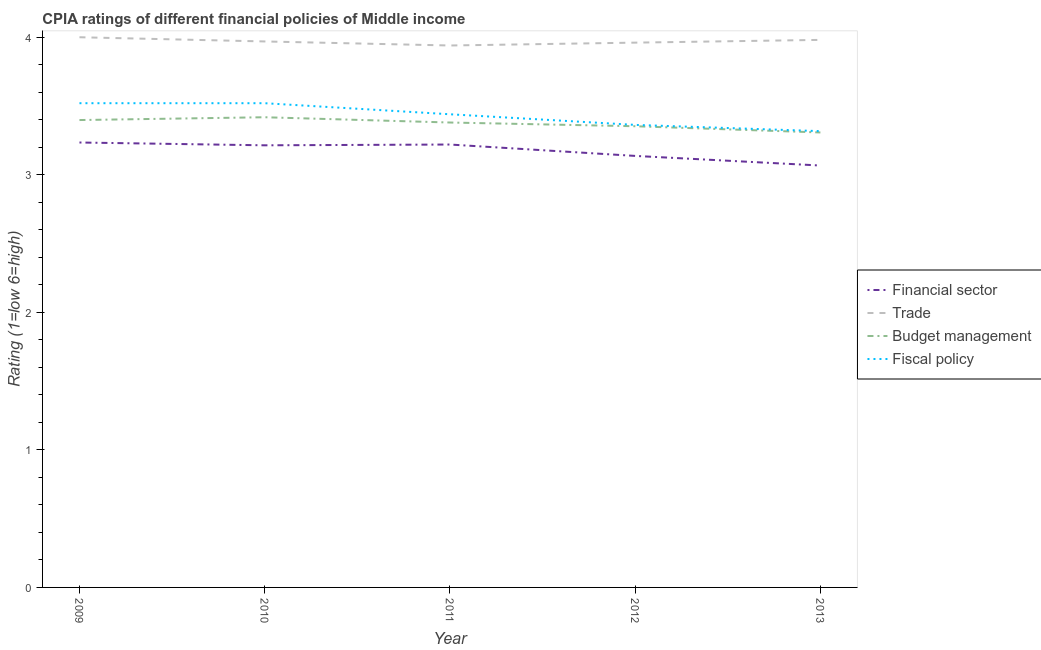How many different coloured lines are there?
Offer a very short reply. 4. Is the number of lines equal to the number of legend labels?
Your answer should be very brief. Yes. What is the cpia rating of fiscal policy in 2010?
Provide a short and direct response. 3.52. Across all years, what is the maximum cpia rating of budget management?
Provide a short and direct response. 3.42. Across all years, what is the minimum cpia rating of budget management?
Make the answer very short. 3.31. In which year was the cpia rating of fiscal policy maximum?
Provide a succinct answer. 2009. In which year was the cpia rating of trade minimum?
Offer a very short reply. 2011. What is the total cpia rating of financial sector in the graph?
Provide a short and direct response. 15.87. What is the difference between the cpia rating of fiscal policy in 2011 and that in 2012?
Your response must be concise. 0.08. What is the difference between the cpia rating of financial sector in 2012 and the cpia rating of fiscal policy in 2010?
Make the answer very short. -0.38. What is the average cpia rating of financial sector per year?
Your response must be concise. 3.17. In the year 2010, what is the difference between the cpia rating of budget management and cpia rating of trade?
Keep it short and to the point. -0.55. In how many years, is the cpia rating of fiscal policy greater than 2.8?
Your response must be concise. 5. What is the ratio of the cpia rating of budget management in 2009 to that in 2011?
Your response must be concise. 1.01. Is the difference between the cpia rating of trade in 2009 and 2011 greater than the difference between the cpia rating of financial sector in 2009 and 2011?
Your response must be concise. Yes. What is the difference between the highest and the second highest cpia rating of trade?
Provide a short and direct response. 0.02. What is the difference between the highest and the lowest cpia rating of budget management?
Provide a short and direct response. 0.11. In how many years, is the cpia rating of financial sector greater than the average cpia rating of financial sector taken over all years?
Your response must be concise. 3. Is it the case that in every year, the sum of the cpia rating of financial sector and cpia rating of trade is greater than the cpia rating of budget management?
Provide a short and direct response. Yes. Does the cpia rating of trade monotonically increase over the years?
Your response must be concise. No. Is the cpia rating of financial sector strictly greater than the cpia rating of budget management over the years?
Offer a terse response. No. Is the cpia rating of budget management strictly less than the cpia rating of financial sector over the years?
Provide a short and direct response. No. How many lines are there?
Ensure brevity in your answer.  4. How many years are there in the graph?
Offer a very short reply. 5. Does the graph contain any zero values?
Make the answer very short. No. Where does the legend appear in the graph?
Keep it short and to the point. Center right. What is the title of the graph?
Provide a short and direct response. CPIA ratings of different financial policies of Middle income. Does "Primary" appear as one of the legend labels in the graph?
Make the answer very short. No. What is the label or title of the X-axis?
Offer a very short reply. Year. What is the label or title of the Y-axis?
Offer a very short reply. Rating (1=low 6=high). What is the Rating (1=low 6=high) in Financial sector in 2009?
Your response must be concise. 3.23. What is the Rating (1=low 6=high) in Budget management in 2009?
Ensure brevity in your answer.  3.4. What is the Rating (1=low 6=high) of Fiscal policy in 2009?
Your answer should be very brief. 3.52. What is the Rating (1=low 6=high) of Financial sector in 2010?
Ensure brevity in your answer.  3.21. What is the Rating (1=low 6=high) in Trade in 2010?
Give a very brief answer. 3.97. What is the Rating (1=low 6=high) of Budget management in 2010?
Your response must be concise. 3.42. What is the Rating (1=low 6=high) of Fiscal policy in 2010?
Your answer should be very brief. 3.52. What is the Rating (1=low 6=high) in Financial sector in 2011?
Your response must be concise. 3.22. What is the Rating (1=low 6=high) of Trade in 2011?
Keep it short and to the point. 3.94. What is the Rating (1=low 6=high) in Budget management in 2011?
Your response must be concise. 3.38. What is the Rating (1=low 6=high) in Fiscal policy in 2011?
Ensure brevity in your answer.  3.44. What is the Rating (1=low 6=high) in Financial sector in 2012?
Give a very brief answer. 3.14. What is the Rating (1=low 6=high) in Trade in 2012?
Make the answer very short. 3.96. What is the Rating (1=low 6=high) in Budget management in 2012?
Offer a very short reply. 3.35. What is the Rating (1=low 6=high) of Fiscal policy in 2012?
Offer a terse response. 3.36. What is the Rating (1=low 6=high) in Financial sector in 2013?
Provide a succinct answer. 3.07. What is the Rating (1=low 6=high) in Trade in 2013?
Offer a very short reply. 3.98. What is the Rating (1=low 6=high) of Budget management in 2013?
Offer a terse response. 3.31. What is the Rating (1=low 6=high) in Fiscal policy in 2013?
Keep it short and to the point. 3.32. Across all years, what is the maximum Rating (1=low 6=high) in Financial sector?
Provide a short and direct response. 3.23. Across all years, what is the maximum Rating (1=low 6=high) in Trade?
Your answer should be compact. 4. Across all years, what is the maximum Rating (1=low 6=high) in Budget management?
Offer a very short reply. 3.42. Across all years, what is the maximum Rating (1=low 6=high) in Fiscal policy?
Your answer should be very brief. 3.52. Across all years, what is the minimum Rating (1=low 6=high) in Financial sector?
Your response must be concise. 3.07. Across all years, what is the minimum Rating (1=low 6=high) of Trade?
Provide a succinct answer. 3.94. Across all years, what is the minimum Rating (1=low 6=high) in Budget management?
Offer a very short reply. 3.31. Across all years, what is the minimum Rating (1=low 6=high) of Fiscal policy?
Give a very brief answer. 3.32. What is the total Rating (1=low 6=high) in Financial sector in the graph?
Give a very brief answer. 15.87. What is the total Rating (1=low 6=high) of Trade in the graph?
Offer a very short reply. 19.85. What is the total Rating (1=low 6=high) in Budget management in the graph?
Keep it short and to the point. 16.86. What is the total Rating (1=low 6=high) of Fiscal policy in the graph?
Your response must be concise. 17.16. What is the difference between the Rating (1=low 6=high) of Financial sector in 2009 and that in 2010?
Your answer should be compact. 0.02. What is the difference between the Rating (1=low 6=high) of Trade in 2009 and that in 2010?
Offer a very short reply. 0.03. What is the difference between the Rating (1=low 6=high) of Budget management in 2009 and that in 2010?
Your answer should be very brief. -0.02. What is the difference between the Rating (1=low 6=high) of Financial sector in 2009 and that in 2011?
Offer a terse response. 0.01. What is the difference between the Rating (1=low 6=high) in Trade in 2009 and that in 2011?
Your response must be concise. 0.06. What is the difference between the Rating (1=low 6=high) in Budget management in 2009 and that in 2011?
Ensure brevity in your answer.  0.02. What is the difference between the Rating (1=low 6=high) in Fiscal policy in 2009 and that in 2011?
Offer a terse response. 0.08. What is the difference between the Rating (1=low 6=high) in Financial sector in 2009 and that in 2012?
Your answer should be very brief. 0.1. What is the difference between the Rating (1=low 6=high) of Trade in 2009 and that in 2012?
Your answer should be compact. 0.04. What is the difference between the Rating (1=low 6=high) of Budget management in 2009 and that in 2012?
Provide a short and direct response. 0.04. What is the difference between the Rating (1=low 6=high) of Fiscal policy in 2009 and that in 2012?
Your response must be concise. 0.16. What is the difference between the Rating (1=low 6=high) in Financial sector in 2009 and that in 2013?
Ensure brevity in your answer.  0.17. What is the difference between the Rating (1=low 6=high) in Trade in 2009 and that in 2013?
Your answer should be very brief. 0.02. What is the difference between the Rating (1=low 6=high) of Budget management in 2009 and that in 2013?
Offer a very short reply. 0.09. What is the difference between the Rating (1=low 6=high) in Fiscal policy in 2009 and that in 2013?
Provide a succinct answer. 0.2. What is the difference between the Rating (1=low 6=high) of Financial sector in 2010 and that in 2011?
Provide a short and direct response. -0.01. What is the difference between the Rating (1=low 6=high) of Trade in 2010 and that in 2011?
Your answer should be very brief. 0.03. What is the difference between the Rating (1=low 6=high) in Budget management in 2010 and that in 2011?
Provide a succinct answer. 0.04. What is the difference between the Rating (1=low 6=high) in Fiscal policy in 2010 and that in 2011?
Offer a very short reply. 0.08. What is the difference between the Rating (1=low 6=high) in Financial sector in 2010 and that in 2012?
Your answer should be compact. 0.08. What is the difference between the Rating (1=low 6=high) of Trade in 2010 and that in 2012?
Provide a succinct answer. 0.01. What is the difference between the Rating (1=low 6=high) in Budget management in 2010 and that in 2012?
Provide a short and direct response. 0.07. What is the difference between the Rating (1=low 6=high) in Fiscal policy in 2010 and that in 2012?
Make the answer very short. 0.16. What is the difference between the Rating (1=low 6=high) in Financial sector in 2010 and that in 2013?
Your response must be concise. 0.15. What is the difference between the Rating (1=low 6=high) in Trade in 2010 and that in 2013?
Provide a short and direct response. -0.01. What is the difference between the Rating (1=low 6=high) of Budget management in 2010 and that in 2013?
Your answer should be very brief. 0.11. What is the difference between the Rating (1=low 6=high) of Fiscal policy in 2010 and that in 2013?
Offer a terse response. 0.2. What is the difference between the Rating (1=low 6=high) in Financial sector in 2011 and that in 2012?
Ensure brevity in your answer.  0.08. What is the difference between the Rating (1=low 6=high) of Trade in 2011 and that in 2012?
Offer a terse response. -0.02. What is the difference between the Rating (1=low 6=high) in Budget management in 2011 and that in 2012?
Give a very brief answer. 0.03. What is the difference between the Rating (1=low 6=high) of Fiscal policy in 2011 and that in 2012?
Provide a succinct answer. 0.08. What is the difference between the Rating (1=low 6=high) in Financial sector in 2011 and that in 2013?
Make the answer very short. 0.15. What is the difference between the Rating (1=low 6=high) of Trade in 2011 and that in 2013?
Give a very brief answer. -0.04. What is the difference between the Rating (1=low 6=high) in Budget management in 2011 and that in 2013?
Your response must be concise. 0.07. What is the difference between the Rating (1=low 6=high) of Fiscal policy in 2011 and that in 2013?
Provide a short and direct response. 0.12. What is the difference between the Rating (1=low 6=high) in Financial sector in 2012 and that in 2013?
Make the answer very short. 0.07. What is the difference between the Rating (1=low 6=high) of Trade in 2012 and that in 2013?
Provide a succinct answer. -0.02. What is the difference between the Rating (1=low 6=high) in Budget management in 2012 and that in 2013?
Your response must be concise. 0.05. What is the difference between the Rating (1=low 6=high) of Fiscal policy in 2012 and that in 2013?
Give a very brief answer. 0.05. What is the difference between the Rating (1=low 6=high) of Financial sector in 2009 and the Rating (1=low 6=high) of Trade in 2010?
Ensure brevity in your answer.  -0.73. What is the difference between the Rating (1=low 6=high) in Financial sector in 2009 and the Rating (1=low 6=high) in Budget management in 2010?
Ensure brevity in your answer.  -0.18. What is the difference between the Rating (1=low 6=high) in Financial sector in 2009 and the Rating (1=low 6=high) in Fiscal policy in 2010?
Offer a very short reply. -0.29. What is the difference between the Rating (1=low 6=high) of Trade in 2009 and the Rating (1=low 6=high) of Budget management in 2010?
Keep it short and to the point. 0.58. What is the difference between the Rating (1=low 6=high) of Trade in 2009 and the Rating (1=low 6=high) of Fiscal policy in 2010?
Keep it short and to the point. 0.48. What is the difference between the Rating (1=low 6=high) in Budget management in 2009 and the Rating (1=low 6=high) in Fiscal policy in 2010?
Ensure brevity in your answer.  -0.12. What is the difference between the Rating (1=low 6=high) in Financial sector in 2009 and the Rating (1=low 6=high) in Trade in 2011?
Your answer should be very brief. -0.71. What is the difference between the Rating (1=low 6=high) of Financial sector in 2009 and the Rating (1=low 6=high) of Budget management in 2011?
Offer a very short reply. -0.15. What is the difference between the Rating (1=low 6=high) of Financial sector in 2009 and the Rating (1=low 6=high) of Fiscal policy in 2011?
Ensure brevity in your answer.  -0.21. What is the difference between the Rating (1=low 6=high) of Trade in 2009 and the Rating (1=low 6=high) of Budget management in 2011?
Your response must be concise. 0.62. What is the difference between the Rating (1=low 6=high) of Trade in 2009 and the Rating (1=low 6=high) of Fiscal policy in 2011?
Ensure brevity in your answer.  0.56. What is the difference between the Rating (1=low 6=high) in Budget management in 2009 and the Rating (1=low 6=high) in Fiscal policy in 2011?
Keep it short and to the point. -0.04. What is the difference between the Rating (1=low 6=high) in Financial sector in 2009 and the Rating (1=low 6=high) in Trade in 2012?
Your answer should be very brief. -0.73. What is the difference between the Rating (1=low 6=high) of Financial sector in 2009 and the Rating (1=low 6=high) of Budget management in 2012?
Provide a succinct answer. -0.12. What is the difference between the Rating (1=low 6=high) in Financial sector in 2009 and the Rating (1=low 6=high) in Fiscal policy in 2012?
Offer a very short reply. -0.13. What is the difference between the Rating (1=low 6=high) of Trade in 2009 and the Rating (1=low 6=high) of Budget management in 2012?
Provide a succinct answer. 0.65. What is the difference between the Rating (1=low 6=high) in Trade in 2009 and the Rating (1=low 6=high) in Fiscal policy in 2012?
Make the answer very short. 0.64. What is the difference between the Rating (1=low 6=high) of Budget management in 2009 and the Rating (1=low 6=high) of Fiscal policy in 2012?
Give a very brief answer. 0.04. What is the difference between the Rating (1=low 6=high) of Financial sector in 2009 and the Rating (1=low 6=high) of Trade in 2013?
Your answer should be compact. -0.75. What is the difference between the Rating (1=low 6=high) in Financial sector in 2009 and the Rating (1=low 6=high) in Budget management in 2013?
Provide a short and direct response. -0.07. What is the difference between the Rating (1=low 6=high) in Financial sector in 2009 and the Rating (1=low 6=high) in Fiscal policy in 2013?
Make the answer very short. -0.08. What is the difference between the Rating (1=low 6=high) in Trade in 2009 and the Rating (1=low 6=high) in Budget management in 2013?
Offer a very short reply. 0.69. What is the difference between the Rating (1=low 6=high) of Trade in 2009 and the Rating (1=low 6=high) of Fiscal policy in 2013?
Provide a short and direct response. 0.68. What is the difference between the Rating (1=low 6=high) of Budget management in 2009 and the Rating (1=low 6=high) of Fiscal policy in 2013?
Your answer should be very brief. 0.08. What is the difference between the Rating (1=low 6=high) of Financial sector in 2010 and the Rating (1=low 6=high) of Trade in 2011?
Give a very brief answer. -0.73. What is the difference between the Rating (1=low 6=high) of Financial sector in 2010 and the Rating (1=low 6=high) of Budget management in 2011?
Offer a very short reply. -0.17. What is the difference between the Rating (1=low 6=high) of Financial sector in 2010 and the Rating (1=low 6=high) of Fiscal policy in 2011?
Give a very brief answer. -0.23. What is the difference between the Rating (1=low 6=high) of Trade in 2010 and the Rating (1=low 6=high) of Budget management in 2011?
Provide a short and direct response. 0.59. What is the difference between the Rating (1=low 6=high) in Trade in 2010 and the Rating (1=low 6=high) in Fiscal policy in 2011?
Offer a terse response. 0.53. What is the difference between the Rating (1=low 6=high) in Budget management in 2010 and the Rating (1=low 6=high) in Fiscal policy in 2011?
Make the answer very short. -0.02. What is the difference between the Rating (1=low 6=high) in Financial sector in 2010 and the Rating (1=low 6=high) in Trade in 2012?
Provide a succinct answer. -0.75. What is the difference between the Rating (1=low 6=high) of Financial sector in 2010 and the Rating (1=low 6=high) of Budget management in 2012?
Make the answer very short. -0.14. What is the difference between the Rating (1=low 6=high) in Financial sector in 2010 and the Rating (1=low 6=high) in Fiscal policy in 2012?
Your answer should be compact. -0.15. What is the difference between the Rating (1=low 6=high) in Trade in 2010 and the Rating (1=low 6=high) in Budget management in 2012?
Provide a succinct answer. 0.62. What is the difference between the Rating (1=low 6=high) of Trade in 2010 and the Rating (1=low 6=high) of Fiscal policy in 2012?
Your answer should be very brief. 0.61. What is the difference between the Rating (1=low 6=high) in Budget management in 2010 and the Rating (1=low 6=high) in Fiscal policy in 2012?
Your response must be concise. 0.06. What is the difference between the Rating (1=low 6=high) in Financial sector in 2010 and the Rating (1=low 6=high) in Trade in 2013?
Your response must be concise. -0.77. What is the difference between the Rating (1=low 6=high) of Financial sector in 2010 and the Rating (1=low 6=high) of Budget management in 2013?
Give a very brief answer. -0.09. What is the difference between the Rating (1=low 6=high) of Financial sector in 2010 and the Rating (1=low 6=high) of Fiscal policy in 2013?
Give a very brief answer. -0.1. What is the difference between the Rating (1=low 6=high) of Trade in 2010 and the Rating (1=low 6=high) of Budget management in 2013?
Ensure brevity in your answer.  0.66. What is the difference between the Rating (1=low 6=high) in Trade in 2010 and the Rating (1=low 6=high) in Fiscal policy in 2013?
Offer a very short reply. 0.65. What is the difference between the Rating (1=low 6=high) in Budget management in 2010 and the Rating (1=low 6=high) in Fiscal policy in 2013?
Offer a terse response. 0.1. What is the difference between the Rating (1=low 6=high) in Financial sector in 2011 and the Rating (1=low 6=high) in Trade in 2012?
Your answer should be compact. -0.74. What is the difference between the Rating (1=low 6=high) of Financial sector in 2011 and the Rating (1=low 6=high) of Budget management in 2012?
Offer a very short reply. -0.13. What is the difference between the Rating (1=low 6=high) of Financial sector in 2011 and the Rating (1=low 6=high) of Fiscal policy in 2012?
Make the answer very short. -0.14. What is the difference between the Rating (1=low 6=high) in Trade in 2011 and the Rating (1=low 6=high) in Budget management in 2012?
Provide a succinct answer. 0.59. What is the difference between the Rating (1=low 6=high) in Trade in 2011 and the Rating (1=low 6=high) in Fiscal policy in 2012?
Your answer should be very brief. 0.58. What is the difference between the Rating (1=low 6=high) of Budget management in 2011 and the Rating (1=low 6=high) of Fiscal policy in 2012?
Provide a succinct answer. 0.02. What is the difference between the Rating (1=low 6=high) of Financial sector in 2011 and the Rating (1=low 6=high) of Trade in 2013?
Offer a terse response. -0.76. What is the difference between the Rating (1=low 6=high) of Financial sector in 2011 and the Rating (1=low 6=high) of Budget management in 2013?
Provide a short and direct response. -0.09. What is the difference between the Rating (1=low 6=high) in Financial sector in 2011 and the Rating (1=low 6=high) in Fiscal policy in 2013?
Offer a very short reply. -0.1. What is the difference between the Rating (1=low 6=high) in Trade in 2011 and the Rating (1=low 6=high) in Budget management in 2013?
Your response must be concise. 0.63. What is the difference between the Rating (1=low 6=high) of Trade in 2011 and the Rating (1=low 6=high) of Fiscal policy in 2013?
Offer a terse response. 0.62. What is the difference between the Rating (1=low 6=high) in Budget management in 2011 and the Rating (1=low 6=high) in Fiscal policy in 2013?
Offer a terse response. 0.06. What is the difference between the Rating (1=low 6=high) of Financial sector in 2012 and the Rating (1=low 6=high) of Trade in 2013?
Your answer should be very brief. -0.84. What is the difference between the Rating (1=low 6=high) of Financial sector in 2012 and the Rating (1=low 6=high) of Budget management in 2013?
Your answer should be compact. -0.17. What is the difference between the Rating (1=low 6=high) in Financial sector in 2012 and the Rating (1=low 6=high) in Fiscal policy in 2013?
Offer a terse response. -0.18. What is the difference between the Rating (1=low 6=high) of Trade in 2012 and the Rating (1=low 6=high) of Budget management in 2013?
Your answer should be compact. 0.65. What is the difference between the Rating (1=low 6=high) in Trade in 2012 and the Rating (1=low 6=high) in Fiscal policy in 2013?
Give a very brief answer. 0.64. What is the difference between the Rating (1=low 6=high) in Budget management in 2012 and the Rating (1=low 6=high) in Fiscal policy in 2013?
Give a very brief answer. 0.04. What is the average Rating (1=low 6=high) of Financial sector per year?
Make the answer very short. 3.17. What is the average Rating (1=low 6=high) in Trade per year?
Ensure brevity in your answer.  3.97. What is the average Rating (1=low 6=high) of Budget management per year?
Your answer should be very brief. 3.37. What is the average Rating (1=low 6=high) in Fiscal policy per year?
Provide a short and direct response. 3.43. In the year 2009, what is the difference between the Rating (1=low 6=high) of Financial sector and Rating (1=low 6=high) of Trade?
Make the answer very short. -0.77. In the year 2009, what is the difference between the Rating (1=low 6=high) of Financial sector and Rating (1=low 6=high) of Budget management?
Provide a short and direct response. -0.16. In the year 2009, what is the difference between the Rating (1=low 6=high) in Financial sector and Rating (1=low 6=high) in Fiscal policy?
Give a very brief answer. -0.29. In the year 2009, what is the difference between the Rating (1=low 6=high) of Trade and Rating (1=low 6=high) of Budget management?
Offer a terse response. 0.6. In the year 2009, what is the difference between the Rating (1=low 6=high) of Trade and Rating (1=low 6=high) of Fiscal policy?
Your answer should be very brief. 0.48. In the year 2009, what is the difference between the Rating (1=low 6=high) of Budget management and Rating (1=low 6=high) of Fiscal policy?
Your response must be concise. -0.12. In the year 2010, what is the difference between the Rating (1=low 6=high) in Financial sector and Rating (1=low 6=high) in Trade?
Make the answer very short. -0.76. In the year 2010, what is the difference between the Rating (1=low 6=high) of Financial sector and Rating (1=low 6=high) of Budget management?
Give a very brief answer. -0.2. In the year 2010, what is the difference between the Rating (1=low 6=high) of Financial sector and Rating (1=low 6=high) of Fiscal policy?
Your answer should be compact. -0.31. In the year 2010, what is the difference between the Rating (1=low 6=high) in Trade and Rating (1=low 6=high) in Budget management?
Offer a terse response. 0.55. In the year 2010, what is the difference between the Rating (1=low 6=high) of Trade and Rating (1=low 6=high) of Fiscal policy?
Make the answer very short. 0.45. In the year 2010, what is the difference between the Rating (1=low 6=high) in Budget management and Rating (1=low 6=high) in Fiscal policy?
Your answer should be compact. -0.1. In the year 2011, what is the difference between the Rating (1=low 6=high) in Financial sector and Rating (1=low 6=high) in Trade?
Ensure brevity in your answer.  -0.72. In the year 2011, what is the difference between the Rating (1=low 6=high) of Financial sector and Rating (1=low 6=high) of Budget management?
Give a very brief answer. -0.16. In the year 2011, what is the difference between the Rating (1=low 6=high) in Financial sector and Rating (1=low 6=high) in Fiscal policy?
Provide a succinct answer. -0.22. In the year 2011, what is the difference between the Rating (1=low 6=high) in Trade and Rating (1=low 6=high) in Budget management?
Offer a very short reply. 0.56. In the year 2011, what is the difference between the Rating (1=low 6=high) of Budget management and Rating (1=low 6=high) of Fiscal policy?
Your response must be concise. -0.06. In the year 2012, what is the difference between the Rating (1=low 6=high) of Financial sector and Rating (1=low 6=high) of Trade?
Offer a terse response. -0.82. In the year 2012, what is the difference between the Rating (1=low 6=high) in Financial sector and Rating (1=low 6=high) in Budget management?
Your response must be concise. -0.22. In the year 2012, what is the difference between the Rating (1=low 6=high) of Financial sector and Rating (1=low 6=high) of Fiscal policy?
Keep it short and to the point. -0.23. In the year 2012, what is the difference between the Rating (1=low 6=high) in Trade and Rating (1=low 6=high) in Budget management?
Keep it short and to the point. 0.61. In the year 2012, what is the difference between the Rating (1=low 6=high) in Trade and Rating (1=low 6=high) in Fiscal policy?
Ensure brevity in your answer.  0.6. In the year 2012, what is the difference between the Rating (1=low 6=high) in Budget management and Rating (1=low 6=high) in Fiscal policy?
Make the answer very short. -0.01. In the year 2013, what is the difference between the Rating (1=low 6=high) of Financial sector and Rating (1=low 6=high) of Trade?
Give a very brief answer. -0.91. In the year 2013, what is the difference between the Rating (1=low 6=high) of Financial sector and Rating (1=low 6=high) of Budget management?
Provide a succinct answer. -0.24. In the year 2013, what is the difference between the Rating (1=low 6=high) of Trade and Rating (1=low 6=high) of Budget management?
Ensure brevity in your answer.  0.67. In the year 2013, what is the difference between the Rating (1=low 6=high) in Trade and Rating (1=low 6=high) in Fiscal policy?
Provide a succinct answer. 0.66. In the year 2013, what is the difference between the Rating (1=low 6=high) of Budget management and Rating (1=low 6=high) of Fiscal policy?
Give a very brief answer. -0.01. What is the ratio of the Rating (1=low 6=high) of Financial sector in 2009 to that in 2010?
Your response must be concise. 1.01. What is the ratio of the Rating (1=low 6=high) of Trade in 2009 to that in 2010?
Offer a terse response. 1.01. What is the ratio of the Rating (1=low 6=high) in Trade in 2009 to that in 2011?
Give a very brief answer. 1.02. What is the ratio of the Rating (1=low 6=high) of Budget management in 2009 to that in 2011?
Provide a short and direct response. 1.01. What is the ratio of the Rating (1=low 6=high) of Fiscal policy in 2009 to that in 2011?
Offer a very short reply. 1.02. What is the ratio of the Rating (1=low 6=high) of Financial sector in 2009 to that in 2012?
Ensure brevity in your answer.  1.03. What is the ratio of the Rating (1=low 6=high) of Trade in 2009 to that in 2012?
Your answer should be very brief. 1.01. What is the ratio of the Rating (1=low 6=high) of Budget management in 2009 to that in 2012?
Keep it short and to the point. 1.01. What is the ratio of the Rating (1=low 6=high) in Fiscal policy in 2009 to that in 2012?
Keep it short and to the point. 1.05. What is the ratio of the Rating (1=low 6=high) of Financial sector in 2009 to that in 2013?
Ensure brevity in your answer.  1.05. What is the ratio of the Rating (1=low 6=high) of Budget management in 2009 to that in 2013?
Offer a terse response. 1.03. What is the ratio of the Rating (1=low 6=high) of Fiscal policy in 2009 to that in 2013?
Offer a very short reply. 1.06. What is the ratio of the Rating (1=low 6=high) of Financial sector in 2010 to that in 2011?
Your response must be concise. 1. What is the ratio of the Rating (1=low 6=high) of Trade in 2010 to that in 2011?
Your answer should be compact. 1.01. What is the ratio of the Rating (1=low 6=high) of Budget management in 2010 to that in 2011?
Make the answer very short. 1.01. What is the ratio of the Rating (1=low 6=high) of Fiscal policy in 2010 to that in 2011?
Your answer should be compact. 1.02. What is the ratio of the Rating (1=low 6=high) in Financial sector in 2010 to that in 2012?
Give a very brief answer. 1.02. What is the ratio of the Rating (1=low 6=high) in Trade in 2010 to that in 2012?
Your response must be concise. 1. What is the ratio of the Rating (1=low 6=high) in Budget management in 2010 to that in 2012?
Give a very brief answer. 1.02. What is the ratio of the Rating (1=low 6=high) in Fiscal policy in 2010 to that in 2012?
Your answer should be compact. 1.05. What is the ratio of the Rating (1=low 6=high) in Financial sector in 2010 to that in 2013?
Make the answer very short. 1.05. What is the ratio of the Rating (1=low 6=high) in Budget management in 2010 to that in 2013?
Your answer should be compact. 1.03. What is the ratio of the Rating (1=low 6=high) of Fiscal policy in 2010 to that in 2013?
Your answer should be compact. 1.06. What is the ratio of the Rating (1=low 6=high) of Financial sector in 2011 to that in 2012?
Your response must be concise. 1.03. What is the ratio of the Rating (1=low 6=high) of Trade in 2011 to that in 2012?
Your response must be concise. 0.99. What is the ratio of the Rating (1=low 6=high) in Budget management in 2011 to that in 2012?
Offer a terse response. 1.01. What is the ratio of the Rating (1=low 6=high) of Financial sector in 2011 to that in 2013?
Give a very brief answer. 1.05. What is the ratio of the Rating (1=low 6=high) in Trade in 2011 to that in 2013?
Keep it short and to the point. 0.99. What is the ratio of the Rating (1=low 6=high) of Budget management in 2011 to that in 2013?
Ensure brevity in your answer.  1.02. What is the ratio of the Rating (1=low 6=high) of Financial sector in 2012 to that in 2013?
Make the answer very short. 1.02. What is the ratio of the Rating (1=low 6=high) in Budget management in 2012 to that in 2013?
Your response must be concise. 1.01. What is the ratio of the Rating (1=low 6=high) of Fiscal policy in 2012 to that in 2013?
Your answer should be compact. 1.01. What is the difference between the highest and the second highest Rating (1=low 6=high) in Financial sector?
Provide a short and direct response. 0.01. What is the difference between the highest and the second highest Rating (1=low 6=high) of Trade?
Provide a short and direct response. 0.02. What is the difference between the highest and the second highest Rating (1=low 6=high) in Budget management?
Your answer should be compact. 0.02. What is the difference between the highest and the second highest Rating (1=low 6=high) of Fiscal policy?
Give a very brief answer. 0. What is the difference between the highest and the lowest Rating (1=low 6=high) in Financial sector?
Your response must be concise. 0.17. What is the difference between the highest and the lowest Rating (1=low 6=high) of Budget management?
Offer a terse response. 0.11. What is the difference between the highest and the lowest Rating (1=low 6=high) of Fiscal policy?
Your answer should be compact. 0.2. 